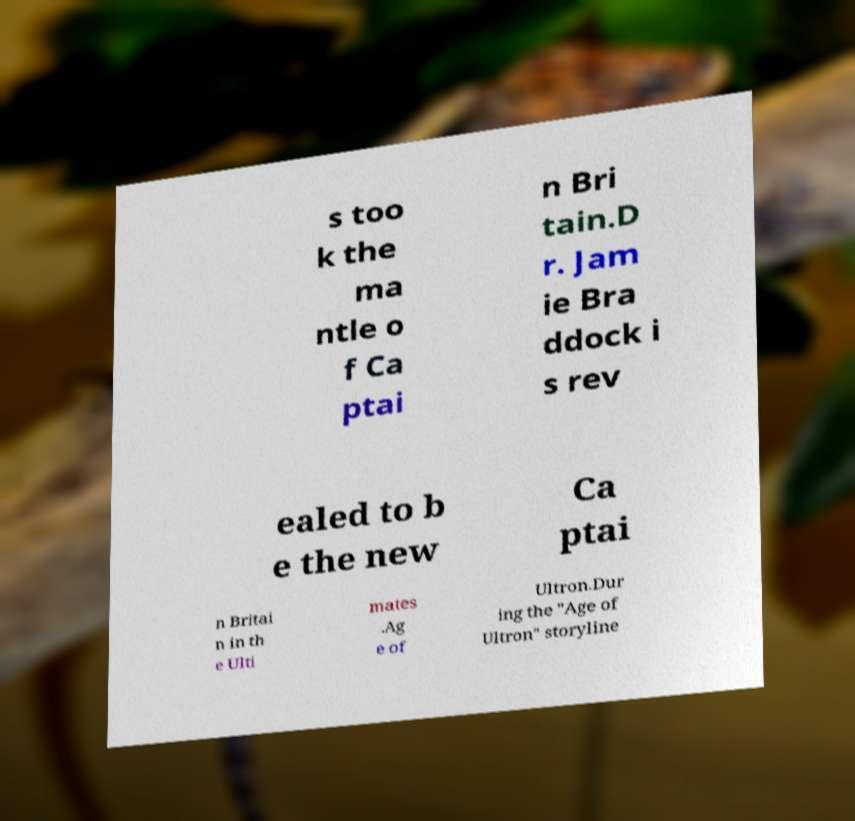Please read and relay the text visible in this image. What does it say? s too k the ma ntle o f Ca ptai n Bri tain.D r. Jam ie Bra ddock i s rev ealed to b e the new Ca ptai n Britai n in th e Ulti mates .Ag e of Ultron.Dur ing the "Age of Ultron" storyline 